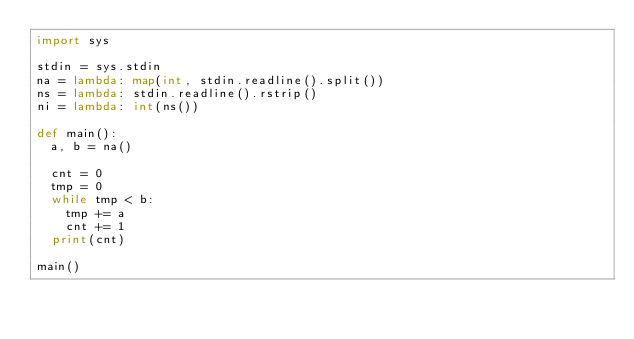Convert code to text. <code><loc_0><loc_0><loc_500><loc_500><_Python_>import sys

stdin = sys.stdin
na = lambda: map(int, stdin.readline().split())
ns = lambda: stdin.readline().rstrip()
ni = lambda: int(ns())

def main():
  a, b = na()
  
  cnt = 0
  tmp = 0
  while tmp < b:
    tmp += a
    cnt += 1
  print(cnt)

main()</code> 